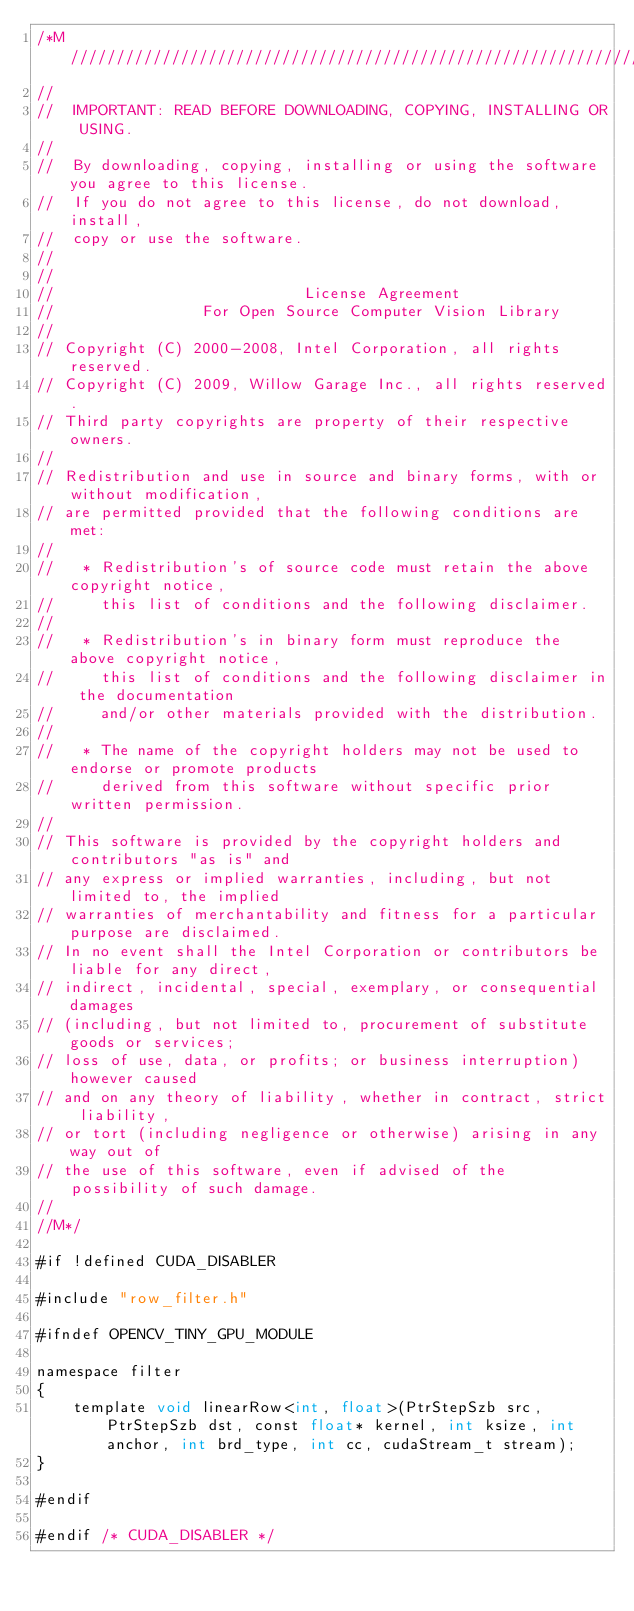Convert code to text. <code><loc_0><loc_0><loc_500><loc_500><_Cuda_>/*M///////////////////////////////////////////////////////////////////////////////////////
//
//  IMPORTANT: READ BEFORE DOWNLOADING, COPYING, INSTALLING OR USING.
//
//  By downloading, copying, installing or using the software you agree to this license.
//  If you do not agree to this license, do not download, install,
//  copy or use the software.
//
//
//                           License Agreement
//                For Open Source Computer Vision Library
//
// Copyright (C) 2000-2008, Intel Corporation, all rights reserved.
// Copyright (C) 2009, Willow Garage Inc., all rights reserved.
// Third party copyrights are property of their respective owners.
//
// Redistribution and use in source and binary forms, with or without modification,
// are permitted provided that the following conditions are met:
//
//   * Redistribution's of source code must retain the above copyright notice,
//     this list of conditions and the following disclaimer.
//
//   * Redistribution's in binary form must reproduce the above copyright notice,
//     this list of conditions and the following disclaimer in the documentation
//     and/or other materials provided with the distribution.
//
//   * The name of the copyright holders may not be used to endorse or promote products
//     derived from this software without specific prior written permission.
//
// This software is provided by the copyright holders and contributors "as is" and
// any express or implied warranties, including, but not limited to, the implied
// warranties of merchantability and fitness for a particular purpose are disclaimed.
// In no event shall the Intel Corporation or contributors be liable for any direct,
// indirect, incidental, special, exemplary, or consequential damages
// (including, but not limited to, procurement of substitute goods or services;
// loss of use, data, or profits; or business interruption) however caused
// and on any theory of liability, whether in contract, strict liability,
// or tort (including negligence or otherwise) arising in any way out of
// the use of this software, even if advised of the possibility of such damage.
//
//M*/

#if !defined CUDA_DISABLER

#include "row_filter.h"

#ifndef OPENCV_TINY_GPU_MODULE

namespace filter
{
    template void linearRow<int, float>(PtrStepSzb src, PtrStepSzb dst, const float* kernel, int ksize, int anchor, int brd_type, int cc, cudaStream_t stream);
}

#endif

#endif /* CUDA_DISABLER */
</code> 